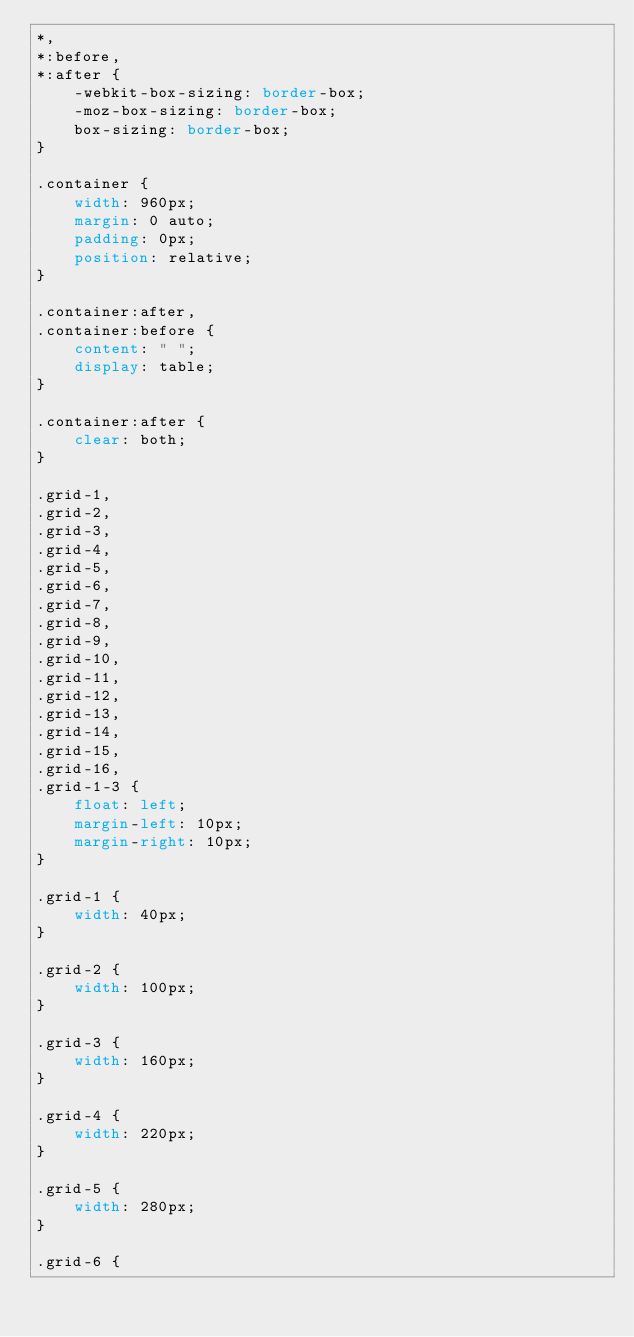<code> <loc_0><loc_0><loc_500><loc_500><_CSS_>*,
*:before,
*:after {
    -webkit-box-sizing: border-box;
    -moz-box-sizing: border-box;
    box-sizing: border-box;
}

.container {
    width: 960px;
    margin: 0 auto;
    padding: 0px;
    position: relative;
}

.container:after,
.container:before {
    content: " ";
    display: table;
}

.container:after {
    clear: both;
}

.grid-1,
.grid-2,
.grid-3,
.grid-4,
.grid-5,
.grid-6,
.grid-7,
.grid-8,
.grid-9,
.grid-10,
.grid-11,
.grid-12,
.grid-13,
.grid-14,
.grid-15,
.grid-16,
.grid-1-3 {
    float: left;
    margin-left: 10px;
    margin-right: 10px;
}

.grid-1 {
    width: 40px;
}

.grid-2 {
    width: 100px;
}

.grid-3 {
    width: 160px;
}

.grid-4 {
    width: 220px;
}

.grid-5 {
    width: 280px;
}

.grid-6 {</code> 